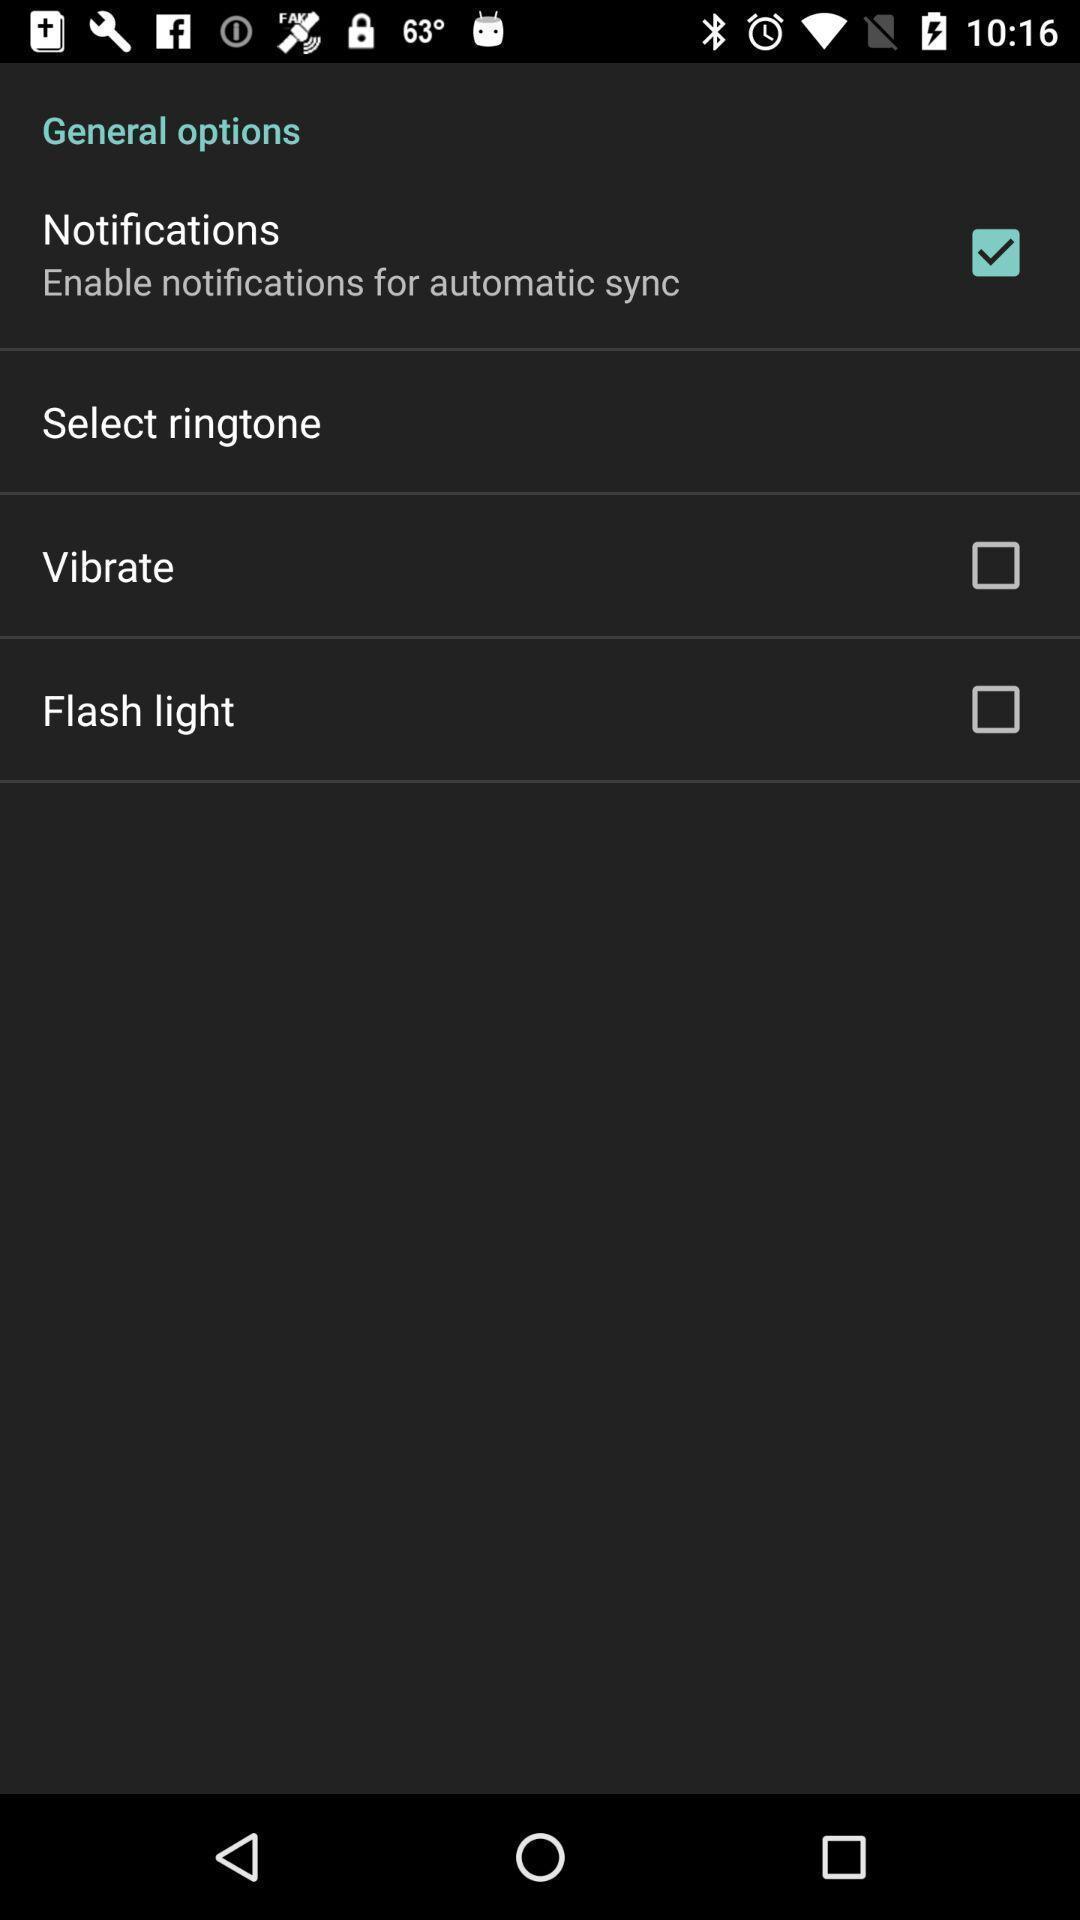What details can you identify in this image? Settings page displaying general options. 